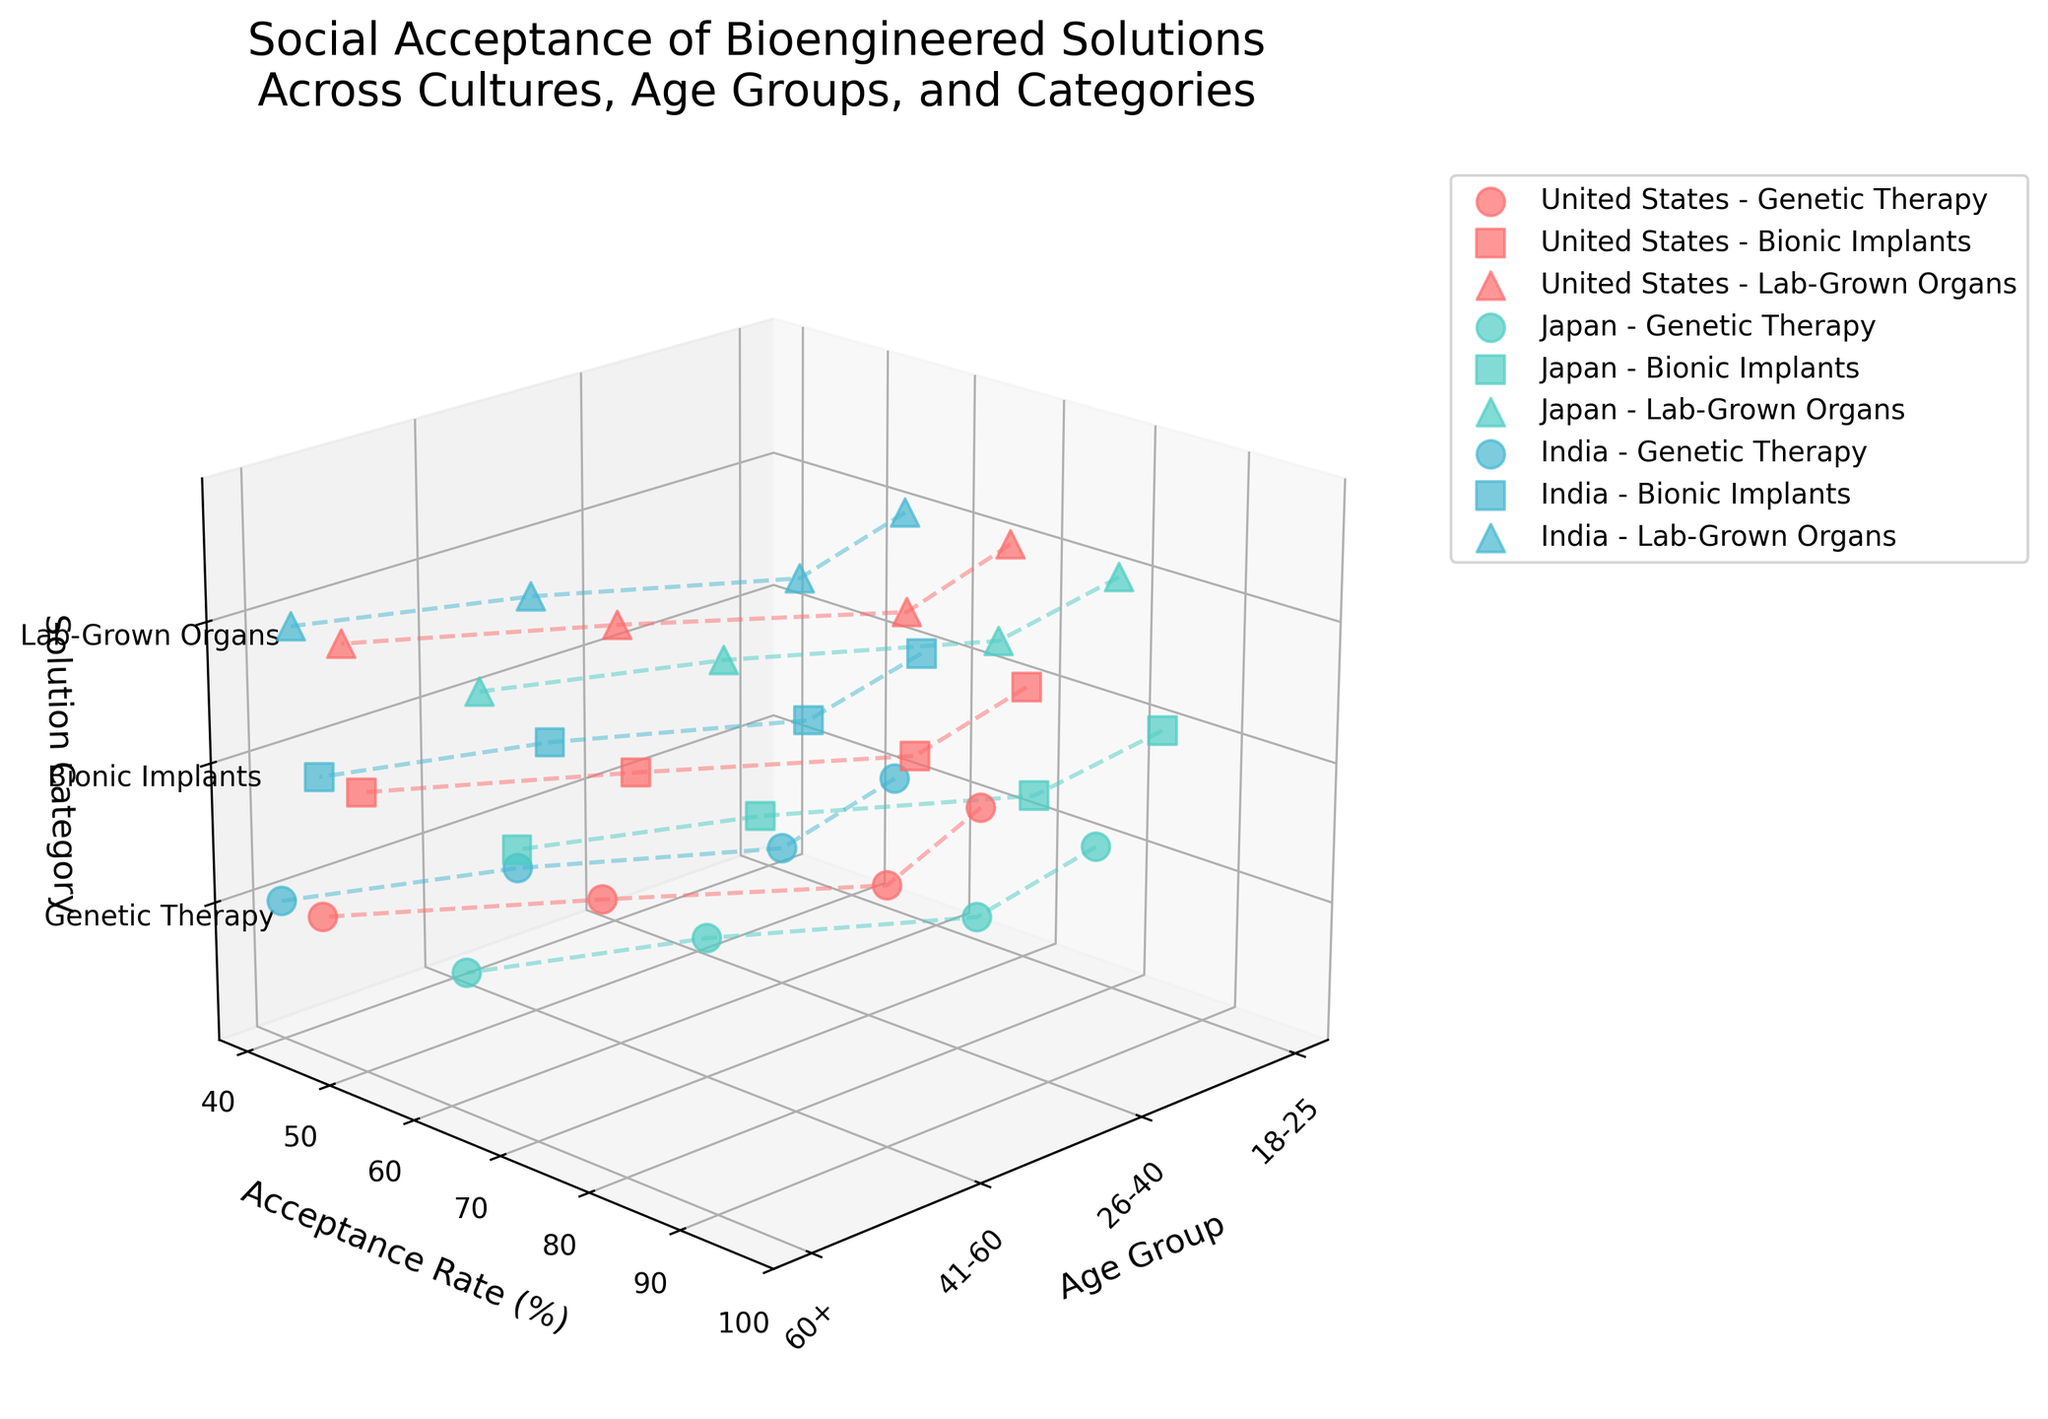What is the title of the figure? The title is usually prominently displayed at the top of the figure. Reading the title gives an overview of what the figure represents.
Answer: Social Acceptance of Bioengineered Solutions Across Cultures, Age Groups, and Categories How many different cultures are represented in the figure? By examining the distinct colored points and corresponding labels in the legend, we notice three different cultures mentioned.
Answer: 3 Which culture has the highest acceptance rate for Genetic Therapy in the age group 26-40? Identify the data points for Genetic Therapy across different age groups and cultures. Look for the highest acceptance rate specifically for the 26-40 age group.
Answer: Japan What is the acceptance rate of Bionic Implants among 60+ individuals in the United States? Locate the data points within the Bionic Implants category for the United States, then find the plot that corresponds to the 60+ age group.
Answer: 50 What age group and solution category have the lowest acceptance rate in India? By comparing all data points for India across different age groups and solution categories, determine which combination has the lowest acceptance rate.
Answer: 60+, Genetic Therapy Calculate the average acceptance rate for Lab-Grown Organs across all age groups in Japan. Extract the acceptance rates for Lab-Grown Organs in Japan, sum them up (80 + 84 + 72 + 64), and divide by the total number of age groups (4).
Answer: 75 Which solution category has the highest overall acceptance rate in the United States? Compare the acceptance rates within each solution category (Genetic Therapy, Bionic Implants, Lab-Grown Organs) for all age groups in the United States, and identify the highest rate among them.
Answer: Bionic Implants Is there any age group in India that shows higher acceptance rates for Bionic Implants compared to Lab-Grown Organs? Compare each age group’s acceptance rates for Bionic Implants and Lab-Grown Organs in India. Check if any age group has a higher acceptance rate for Bionic Implants than for Lab-Grown Organs.
Answer: 18-25, 26-40, 41-60, 60+ What is the average acceptance rate of all bioengineered solutions in the United States for the 18-25 age group? Sum the acceptance rates for the 18-25 age group across all solution categories in the United States (65 + 70 + 68), and divide by the total number of solution categories (3).
Answer: 67.67 Which culture shows the greatest difference in acceptance rates between the age groups 18-25 and 60+ for Genetic Therapy? Compare the acceptance rates for Genetic Therapy between the age groups 18-25 and 60+ in each culture, and calculate the differences (abs(United States: 65-45), abs(Japan: 78-62), abs(India: 55-40)). Identify the culture with the greatest difference.
Answer: United States 